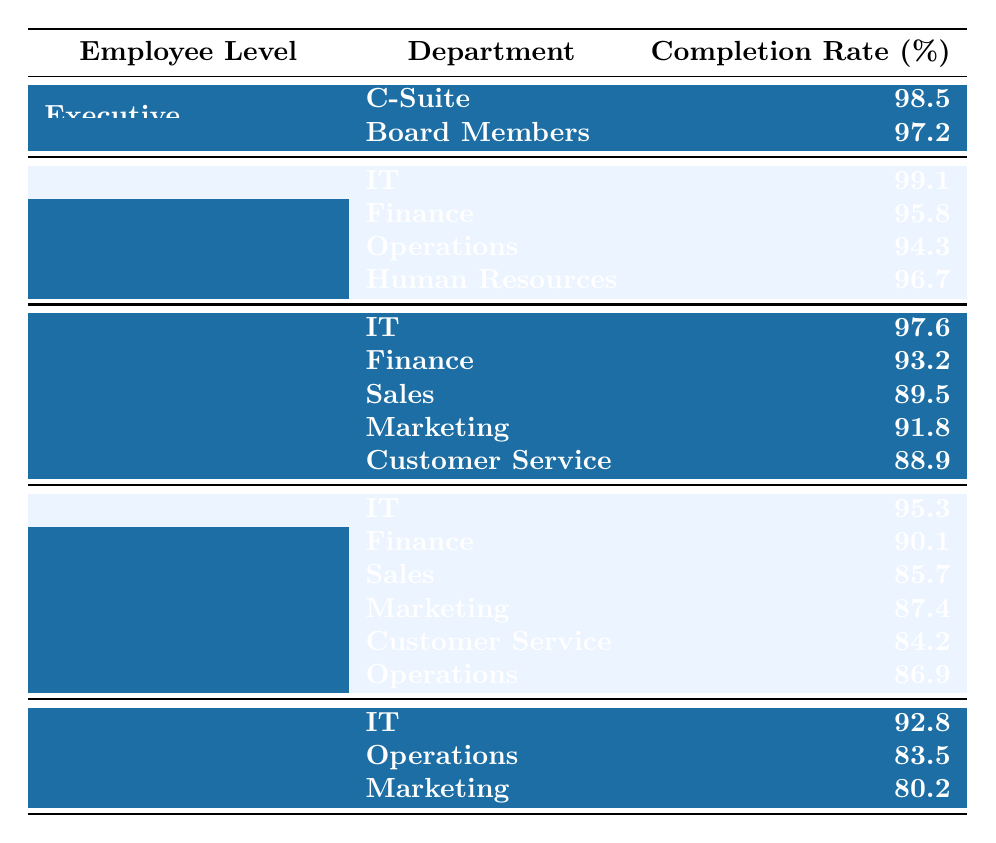What is the completion rate for the IT department in Senior Management? The completion rate for the IT department is listed directly under Senior Management, which is 99.1%.
Answer: 99.1 Which department has the lowest cybersecurity training completion rate among Entry-Level employees? The completion rates for Entry-Level employees in various departments are compared: IT is 95.3, Finance is 90.1, Sales is 85.7, Marketing is 87.4, Customer Service is 84.2, and Operations is 86.9. The lowest is Sales at 85.7%.
Answer: Sales Is the completion rate for Board Members higher than that of the Finance department in Senior Management? The completion rate for Board Members is 97.2% and for Finance in Senior Management, it is 95.8%. Since 97.2% is greater than 95.8%, the answer is yes.
Answer: Yes What is the average completion rate for the Customer Service department across all employee levels? The Customer Service completion rate is listed for Middle Management at 88.9% and for Entry-Level at 84.2%. The average is (88.9 + 84.2) / 2 = 86.55%.
Answer: 86.55 Which employee level has the highest overall cybersecurity training completion rates based on the provided data? To determine this, we look at the completion rates: Executive has a highest average of (98.5 + 97.2) / 2 = 97.85%, Senior Management has (99.1 + 95.8 + 94.3 + 96.7) / 4 = 96.52%, Middle Management has (97.6 + 93.2 + 89.5 + 91.8 + 88.9) / 5 = 92.2%, Entry-Level has (95.3 + 90.1 + 85.7 + 87.4 + 84.2 + 86.9) / 6 = 87.51%, and Contractors has (92.8 + 83.5 + 80.2) / 3 = 85.5%. The highest average is from Executives.
Answer: Executive Which department under Middle Management has the highest training completion rate? The completion rates for Middle Management are as follows: IT at 97.6%, Finance at 93.2%, Sales at 89.5%, Marketing at 91.8%, and Customer Service at 88.9%. The highest is IT at 97.6%.
Answer: IT How many departments have completion rates below 85% among Entry-Level employees? The completion rates for Entry-Level employees are as follows: IT at 95.3%, Finance at 90.1%, Sales at 85.7%, Marketing at 87.4%, Customer Service at 84.2%, and Operations at 86.9%. The only department below 85% is Customer Service.
Answer: 1 What is the difference in completion rates between the highest and lowest departments in Contractors? In the Contractors category, IT has a completion rate of 92.8%, while Marketing is at 80.2%. Thus, the difference is 92.8 – 80.2 = 12.6%.
Answer: 12.6 Is there any department in Senior Management with a completion rate of 94% or lower? The completion rates in Senior Management are: IT at 99.1%, Finance at 95.8%, Operations at 94.3%, and Human Resources at 96.7%. Operations is the only department at 94.3%, which is below 94%. The answer is yes.
Answer: Yes What is the overall completion rate for the IT department across all employee levels? The completion rates for the IT department are 99.1% (Senior Management), 97.6% (Middle Management), 95.3% (Entry-Level), and 92.8% (Contractors). Therefore, the average is (99.1 + 97.6 + 95.3 + 92.8) / 4 = 96.225%.
Answer: 96.225 